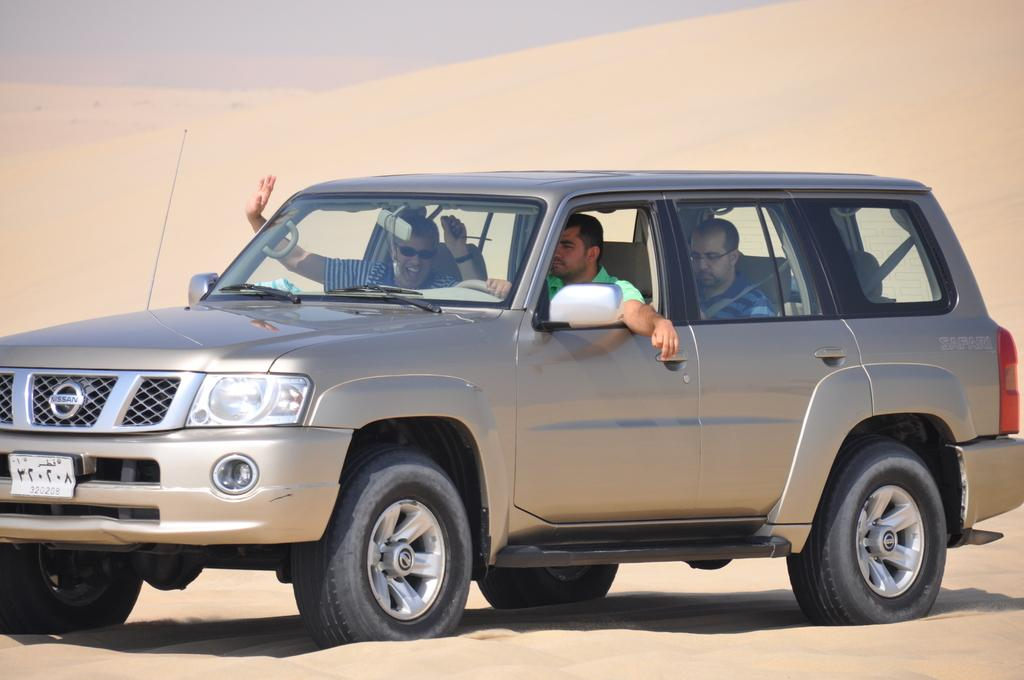How many people are in the car in the image? There are three people sitting in a car in the image. What is the person on the left doing? The person on the left is raising their hands. What type of environment is the car in? The car is in a desert setting. What type of weather is occurring during the recess in the image? There is no recess or weather mentioned in the image; it only shows three people sitting in a car in a desert setting. 